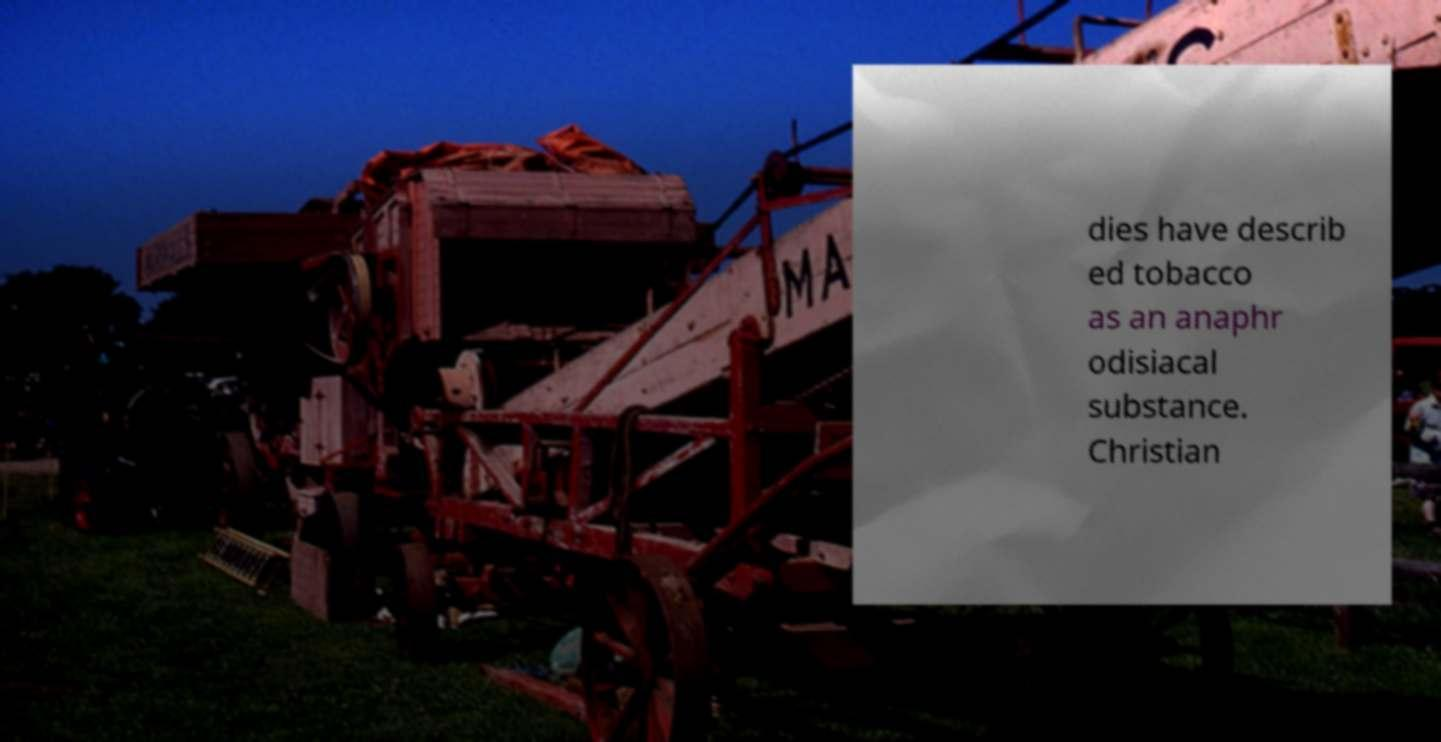Can you read and provide the text displayed in the image? This photo seems to have some interesting text. Can you extract and type it out for me? Certainly! The image displays a partial text that reads: 'dies have described tobacco as an anaphrodisiacal substance. Christian.' Based on the available portion, it seems to discuss an interesting perspective on tobacco, possibly in a broader context of effects or beliefs. 